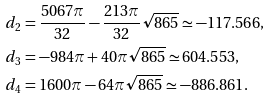<formula> <loc_0><loc_0><loc_500><loc_500>d _ { 2 } & = \frac { 5 0 6 7 \pi } { 3 2 } - \frac { 2 1 3 \pi } { 3 2 } \sqrt { 8 6 5 } \simeq - 1 1 7 . 5 6 6 , \\ d _ { 3 } & = - 9 8 4 \pi + 4 0 \pi \sqrt { 8 6 5 } \simeq 6 0 4 . 5 5 3 , \\ d _ { 4 } & = 1 6 0 0 \pi - 6 4 \pi \sqrt { 8 6 5 } \simeq - 8 8 6 . 8 6 1 .</formula> 